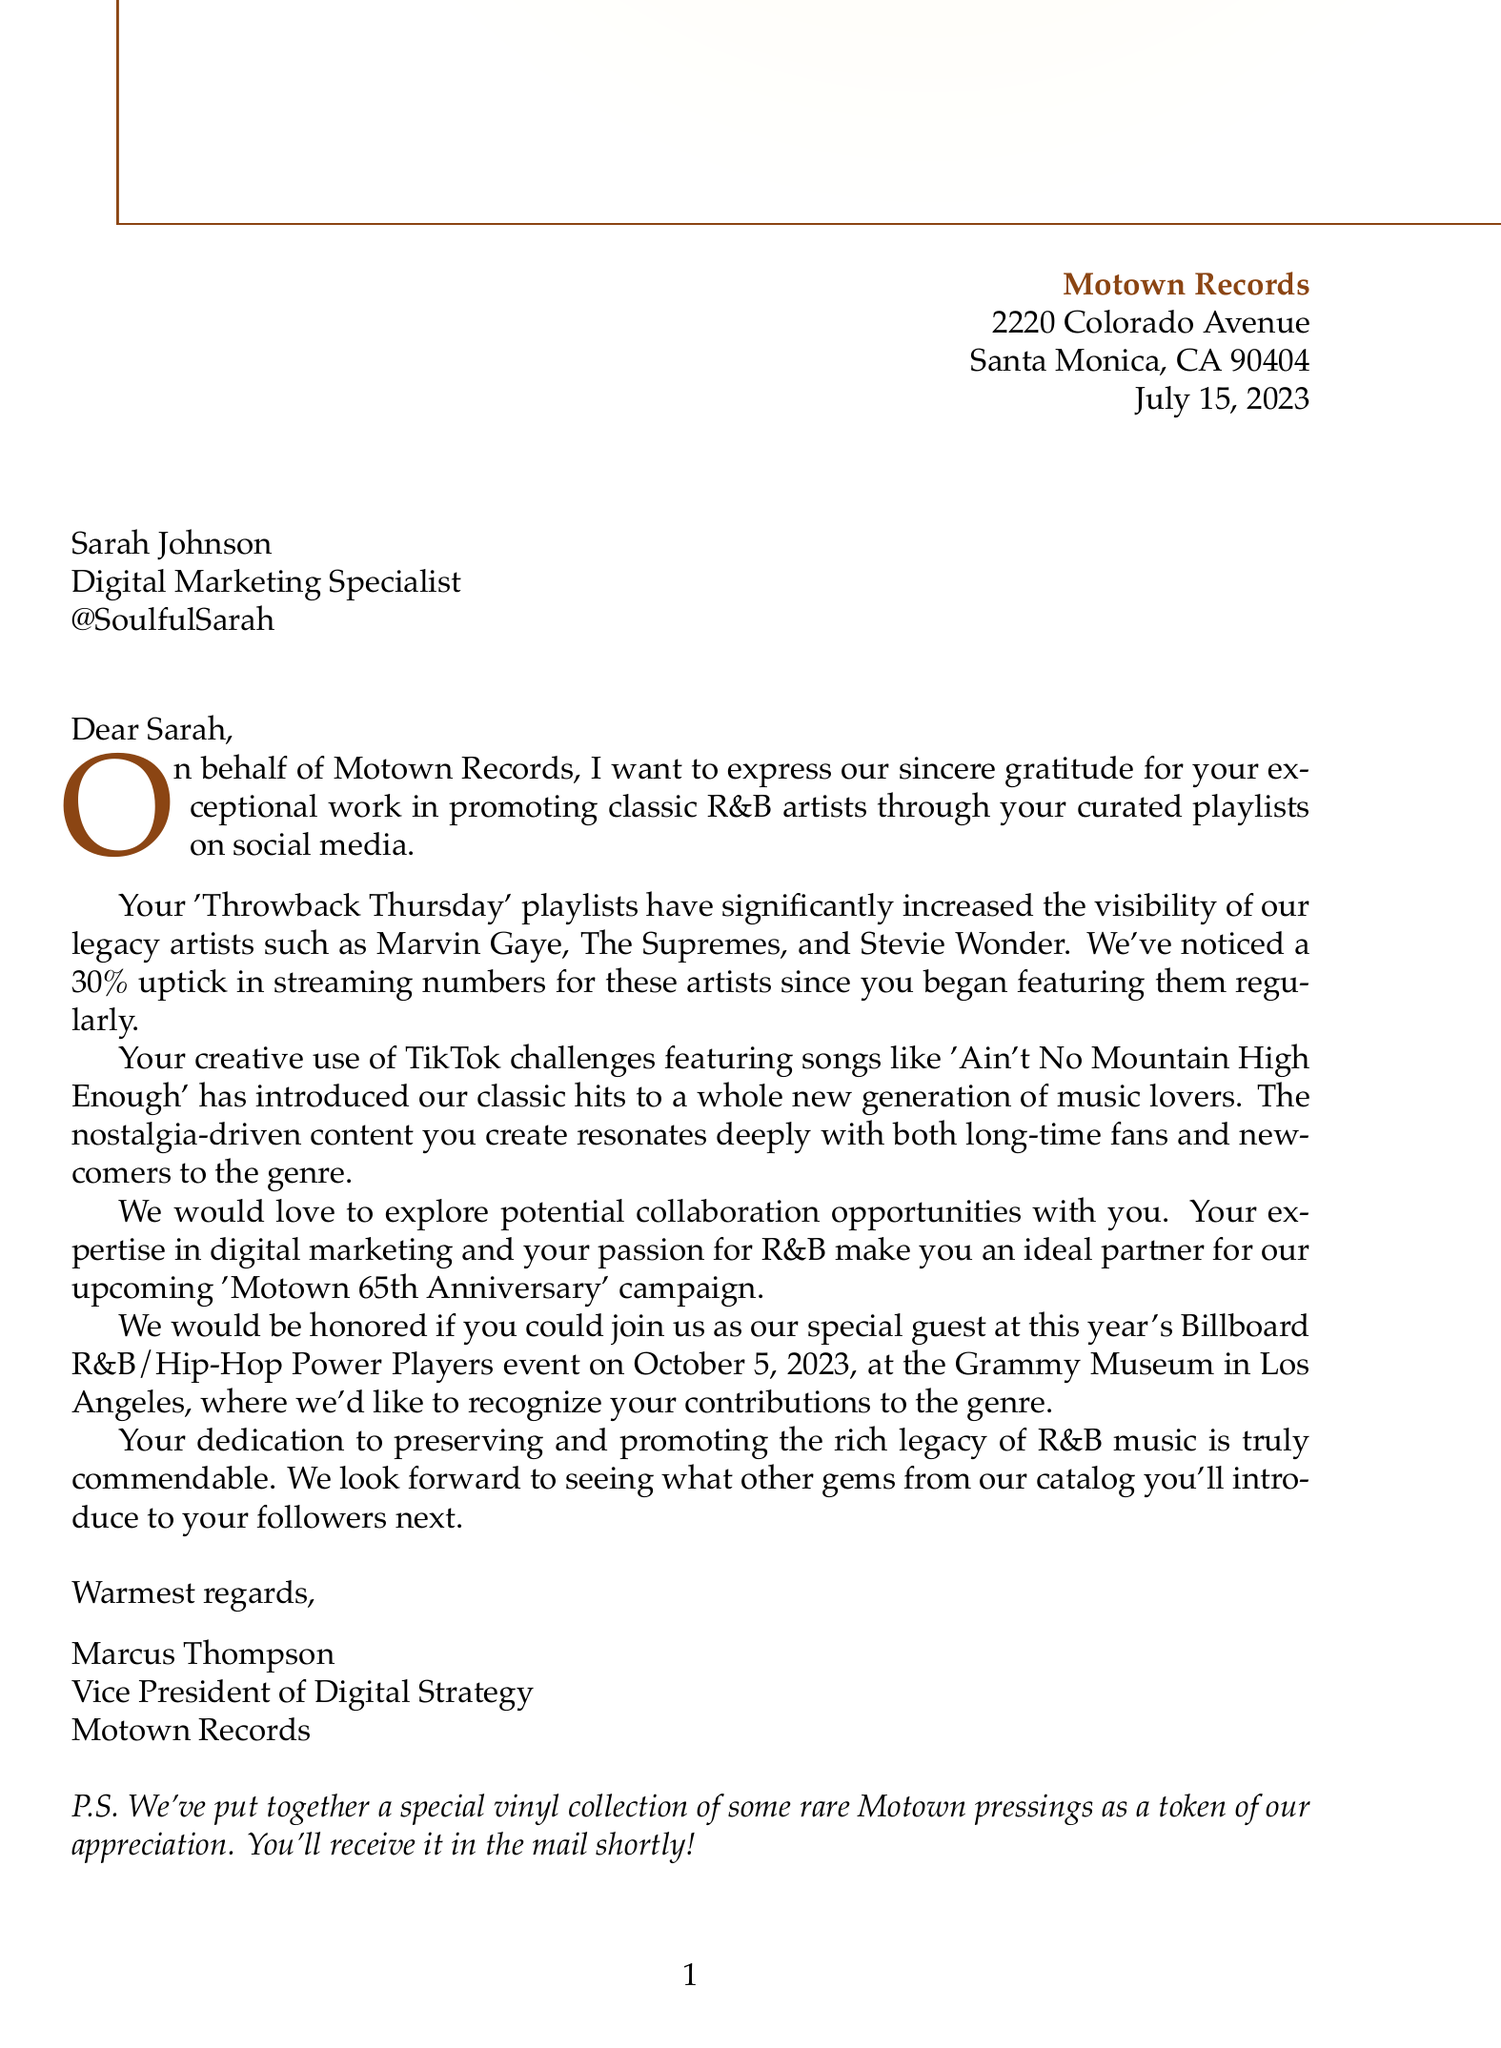what is the name of the record label? The name of the record label is mentioned in the letter's header.
Answer: Motown Records who is the recipient of the letter? The recipient's name is provided in the address section of the letter.
Answer: Sarah Johnson what is the date of the letter? The date is specified in the letter's header.
Answer: July 15, 2023 what event is mentioned in the letter? The letter references a specific event taking place in October, as stated in the body paragraphs.
Answer: Billboard R&B/Hip-Hop Power Players event what percentage increase was noted in streaming numbers for legacy artists? This percentage is detailed in the section discussing the impact on artist visibility.
Answer: 30% which classic R&B artist's song was featured in TikTok challenges? The document specifically mentions a song used in TikTok challenges.
Answer: Ain't No Mountain High Enough what is offered as a token of appreciation in the postscript? The postscript reveals a special item being sent as gratitude.
Answer: special vinyl collection who signed the letter? The signatory's name and title are given at the end of the letter.
Answer: Marcus Thompson what is the purpose of this letter? The overall intent of the letter can be inferred from its opening statement and closing remarks.
Answer: Thank you for promoting classic R&B artists 